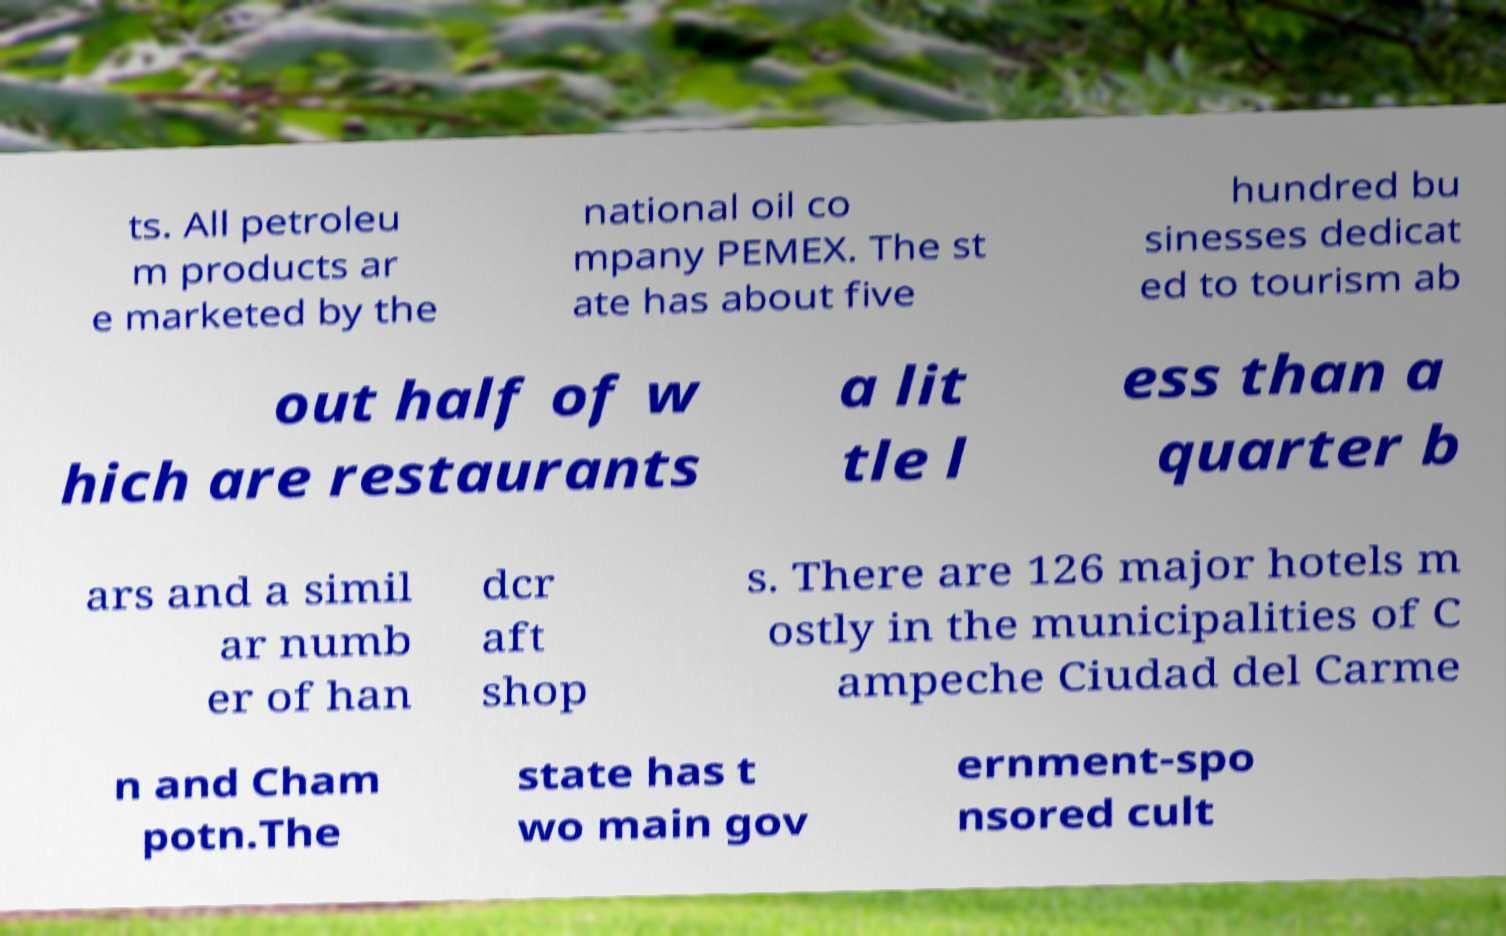Could you assist in decoding the text presented in this image and type it out clearly? ts. All petroleu m products ar e marketed by the national oil co mpany PEMEX. The st ate has about five hundred bu sinesses dedicat ed to tourism ab out half of w hich are restaurants a lit tle l ess than a quarter b ars and a simil ar numb er of han dcr aft shop s. There are 126 major hotels m ostly in the municipalities of C ampeche Ciudad del Carme n and Cham potn.The state has t wo main gov ernment-spo nsored cult 